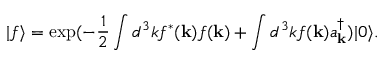Convert formula to latex. <formula><loc_0><loc_0><loc_500><loc_500>| f \rangle = \exp ( - \frac { 1 } { 2 } \int d ^ { 3 } k f ^ { \ast } ( { k } ) f ( { k } ) + \int d ^ { 3 } k f ( { k } ) a _ { k } ^ { \dagger } ) | 0 \rangle .</formula> 